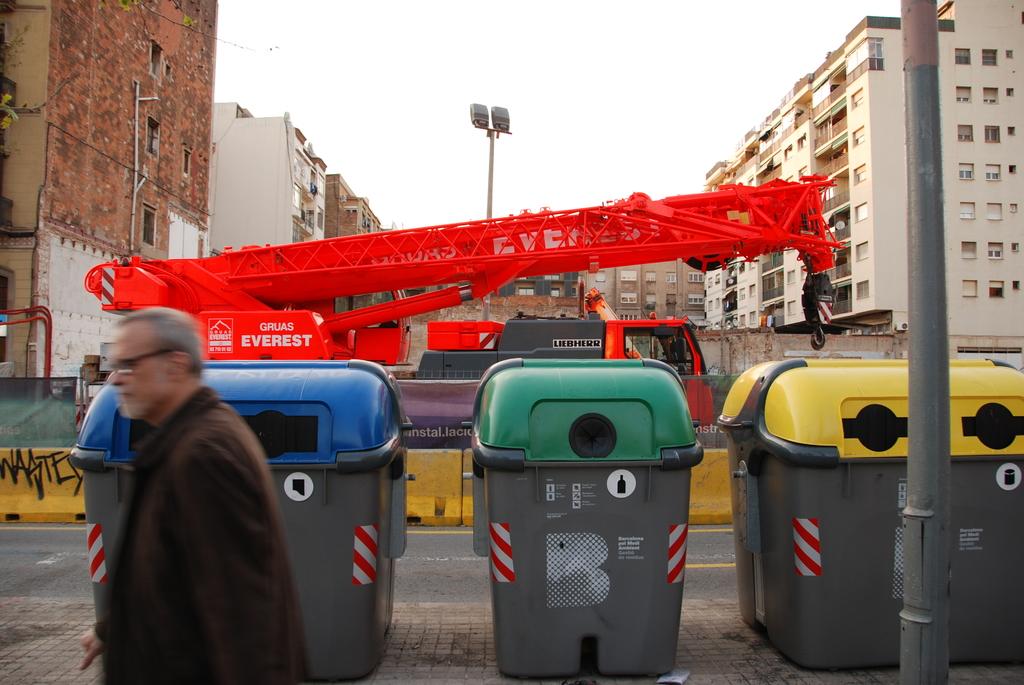What is the name on the red truck?
Offer a very short reply. Everest. What letter is on the middle can?
Provide a short and direct response. B. 